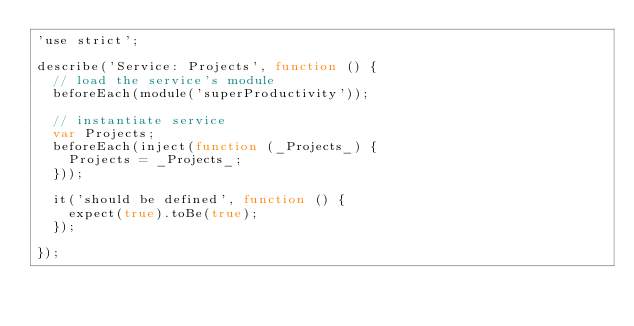Convert code to text. <code><loc_0><loc_0><loc_500><loc_500><_JavaScript_>'use strict';

describe('Service: Projects', function () {
  // load the service's module
  beforeEach(module('superProductivity'));

  // instantiate service
  var Projects;
  beforeEach(inject(function (_Projects_) {
    Projects = _Projects_;
  }));

  it('should be defined', function () {
    expect(true).toBe(true);
  });

});</code> 